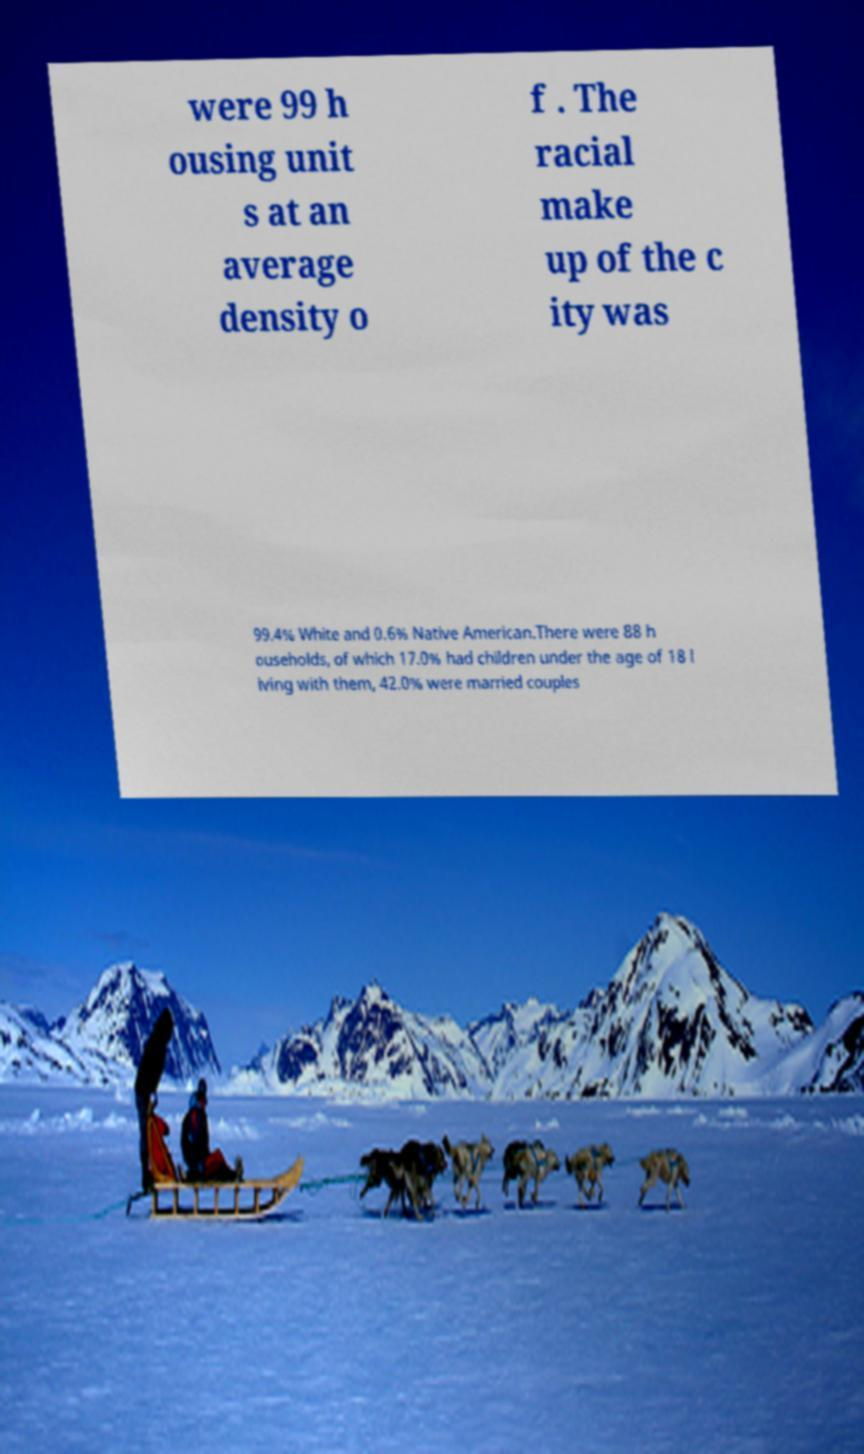Could you assist in decoding the text presented in this image and type it out clearly? were 99 h ousing unit s at an average density o f . The racial make up of the c ity was 99.4% White and 0.6% Native American.There were 88 h ouseholds, of which 17.0% had children under the age of 18 l iving with them, 42.0% were married couples 